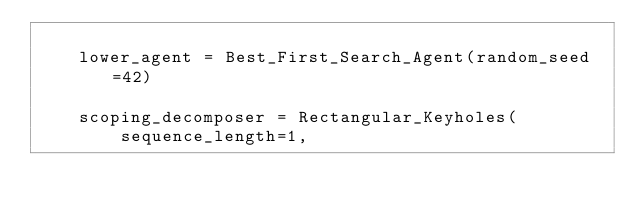<code> <loc_0><loc_0><loc_500><loc_500><_Python_>
    lower_agent = Best_First_Search_Agent(random_seed=42)

    scoping_decomposer = Rectangular_Keyholes(
        sequence_length=1,</code> 